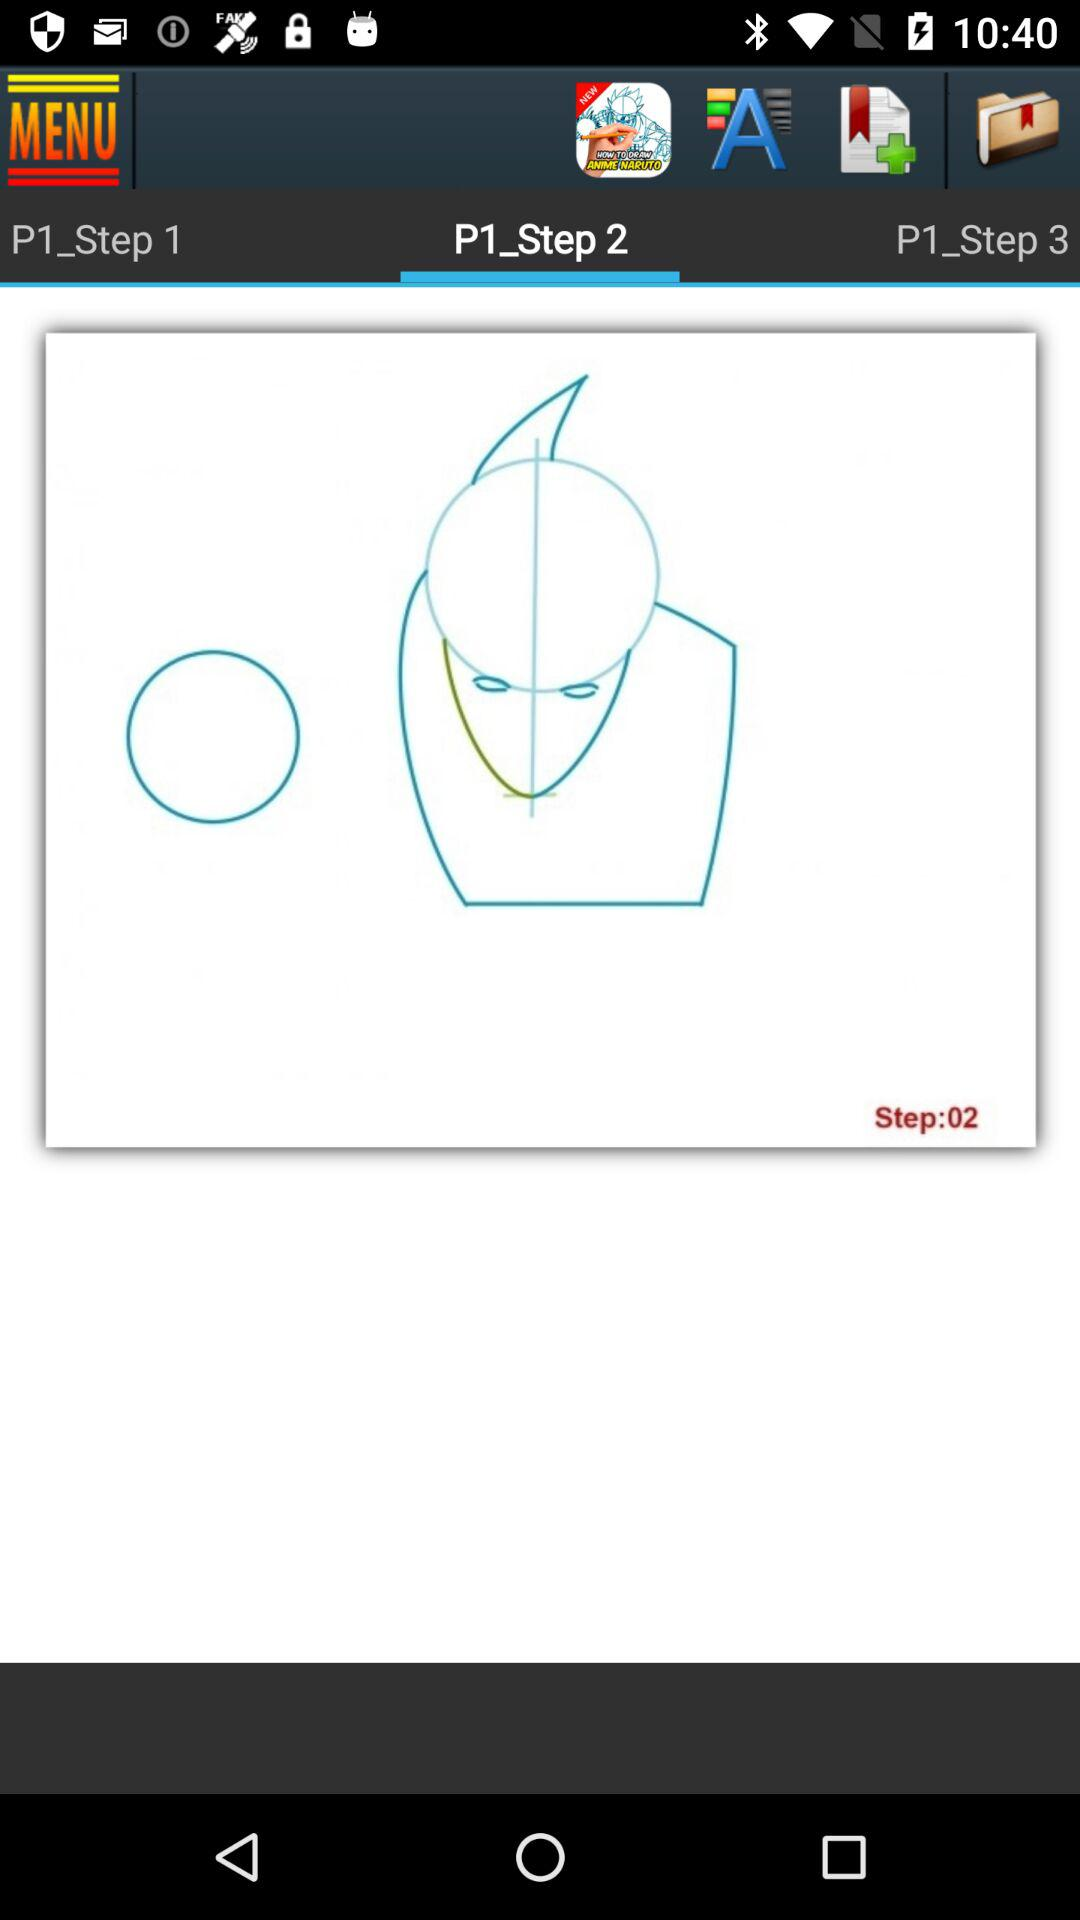How many steps are there in the tutorial?
Answer the question using a single word or phrase. 3 